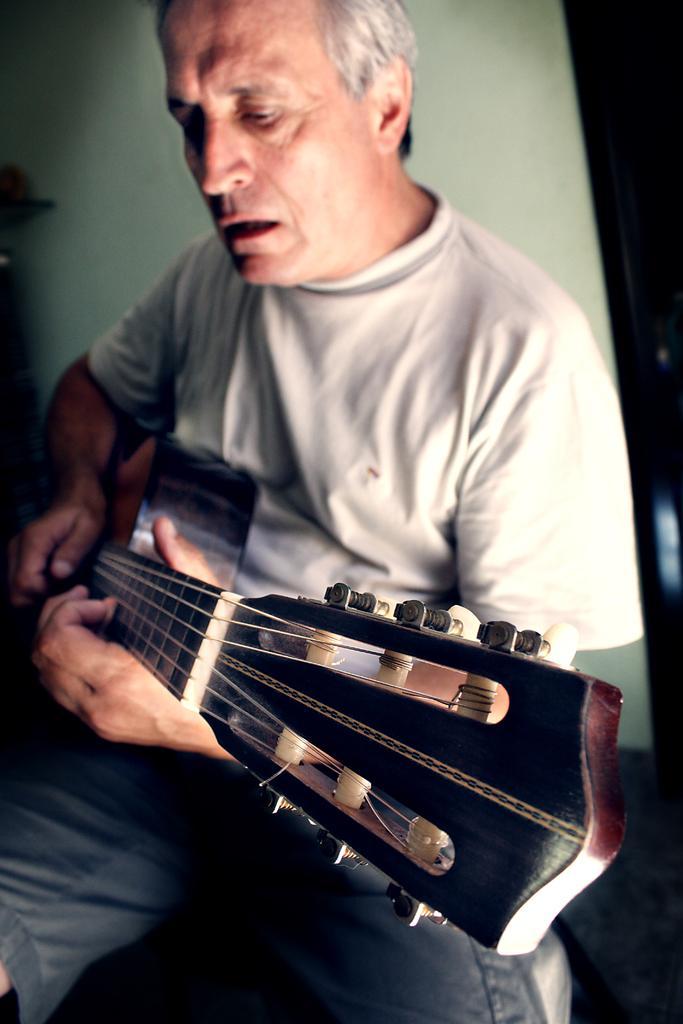In one or two sentences, can you explain what this image depicts? This picture shows a man seated and playing guitar and he wore a white t-shirt and a short 